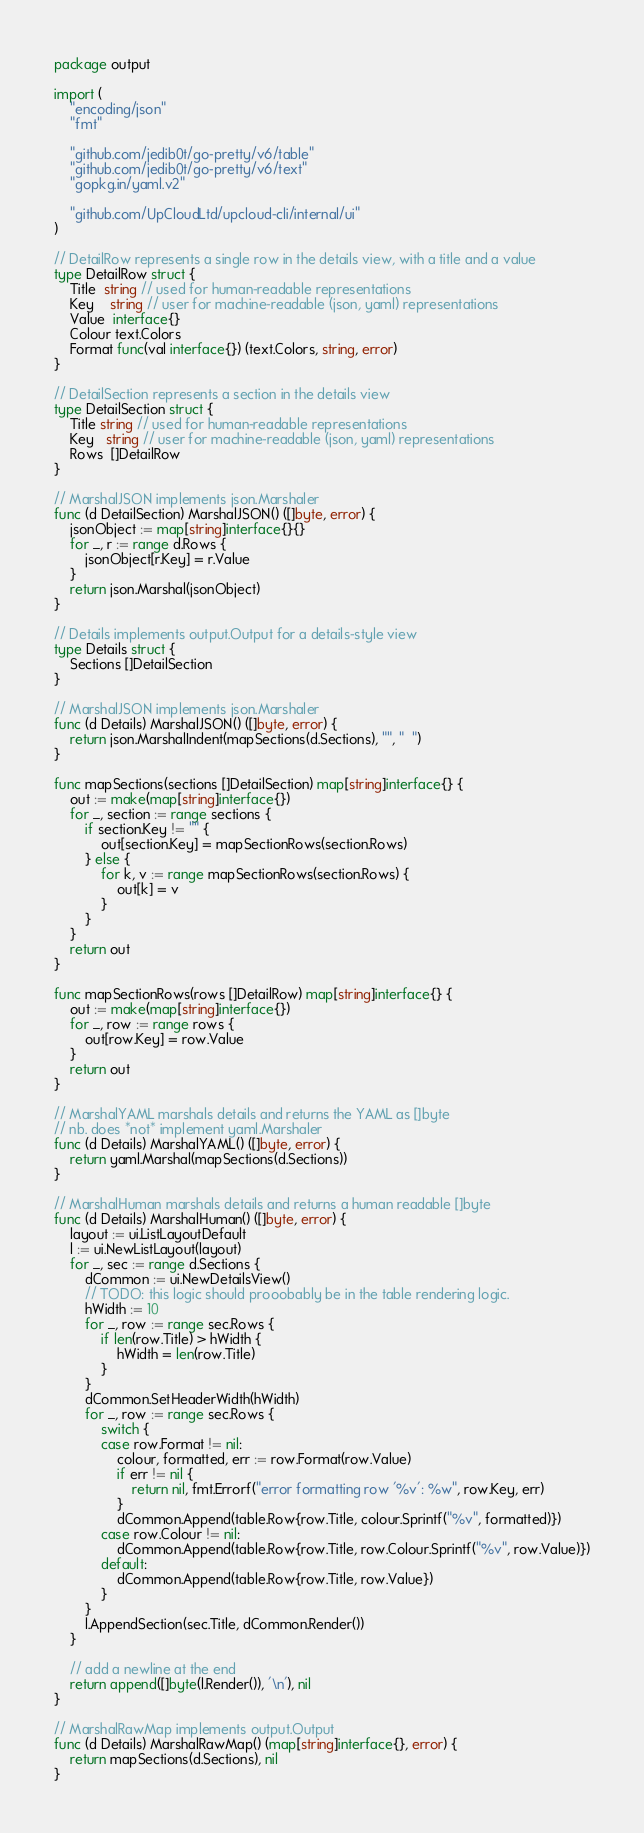Convert code to text. <code><loc_0><loc_0><loc_500><loc_500><_Go_>package output

import (
	"encoding/json"
	"fmt"

	"github.com/jedib0t/go-pretty/v6/table"
	"github.com/jedib0t/go-pretty/v6/text"
	"gopkg.in/yaml.v2"

	"github.com/UpCloudLtd/upcloud-cli/internal/ui"
)

// DetailRow represents a single row in the details view, with a title and a value
type DetailRow struct {
	Title  string // used for human-readable representations
	Key    string // user for machine-readable (json, yaml) representations
	Value  interface{}
	Colour text.Colors
	Format func(val interface{}) (text.Colors, string, error)
}

// DetailSection represents a section in the details view
type DetailSection struct {
	Title string // used for human-readable representations
	Key   string // user for machine-readable (json, yaml) representations
	Rows  []DetailRow
}

// MarshalJSON implements json.Marshaler
func (d DetailSection) MarshalJSON() ([]byte, error) {
	jsonObject := map[string]interface{}{}
	for _, r := range d.Rows {
		jsonObject[r.Key] = r.Value
	}
	return json.Marshal(jsonObject)
}

// Details implements output.Output for a details-style view
type Details struct {
	Sections []DetailSection
}

// MarshalJSON implements json.Marshaler
func (d Details) MarshalJSON() ([]byte, error) {
	return json.MarshalIndent(mapSections(d.Sections), "", "  ")
}

func mapSections(sections []DetailSection) map[string]interface{} {
	out := make(map[string]interface{})
	for _, section := range sections {
		if section.Key != "" {
			out[section.Key] = mapSectionRows(section.Rows)
		} else {
			for k, v := range mapSectionRows(section.Rows) {
				out[k] = v
			}
		}
	}
	return out
}

func mapSectionRows(rows []DetailRow) map[string]interface{} {
	out := make(map[string]interface{})
	for _, row := range rows {
		out[row.Key] = row.Value
	}
	return out
}

// MarshalYAML marshals details and returns the YAML as []byte
// nb. does *not* implement yaml.Marshaler
func (d Details) MarshalYAML() ([]byte, error) {
	return yaml.Marshal(mapSections(d.Sections))
}

// MarshalHuman marshals details and returns a human readable []byte
func (d Details) MarshalHuman() ([]byte, error) {
	layout := ui.ListLayoutDefault
	l := ui.NewListLayout(layout)
	for _, sec := range d.Sections {
		dCommon := ui.NewDetailsView()
		// TODO: this logic should prooobably be in the table rendering logic.
		hWidth := 10
		for _, row := range sec.Rows {
			if len(row.Title) > hWidth {
				hWidth = len(row.Title)
			}
		}
		dCommon.SetHeaderWidth(hWidth)
		for _, row := range sec.Rows {
			switch {
			case row.Format != nil:
				colour, formatted, err := row.Format(row.Value)
				if err != nil {
					return nil, fmt.Errorf("error formatting row '%v': %w", row.Key, err)
				}
				dCommon.Append(table.Row{row.Title, colour.Sprintf("%v", formatted)})
			case row.Colour != nil:
				dCommon.Append(table.Row{row.Title, row.Colour.Sprintf("%v", row.Value)})
			default:
				dCommon.Append(table.Row{row.Title, row.Value})
			}
		}
		l.AppendSection(sec.Title, dCommon.Render())
	}

	// add a newline at the end
	return append([]byte(l.Render()), '\n'), nil
}

// MarshalRawMap implements output.Output
func (d Details) MarshalRawMap() (map[string]interface{}, error) {
	return mapSections(d.Sections), nil
}
</code> 